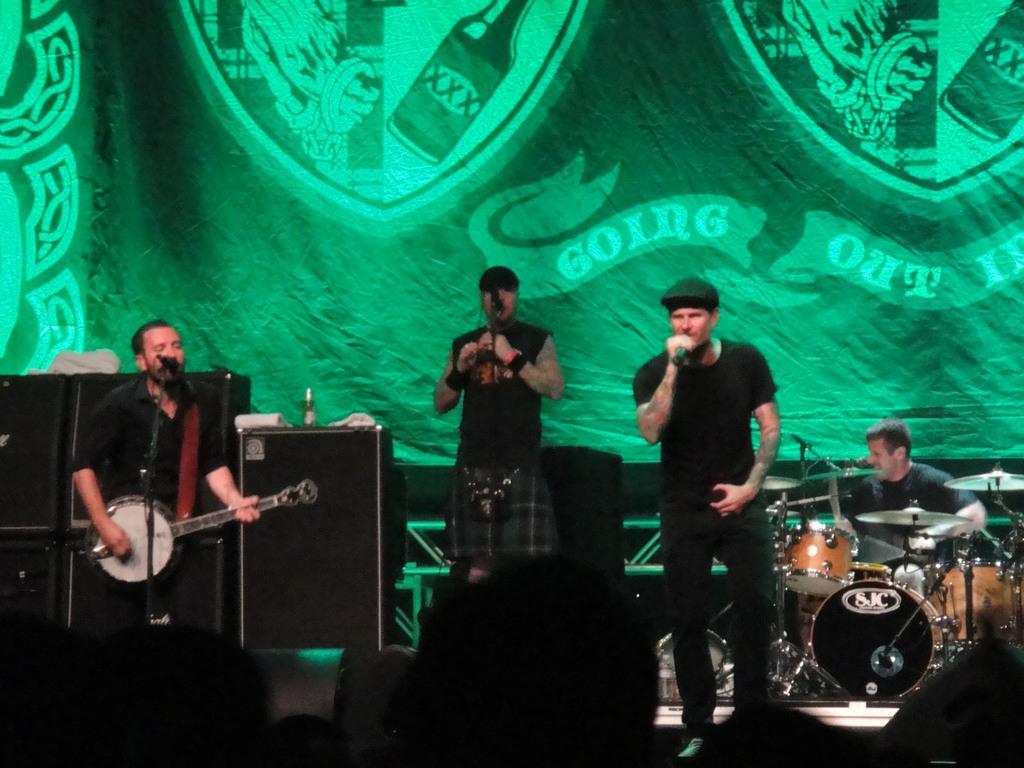Describe this image in one or two sentences. There are three people standing and singing a song. This is a speaker. Here is another person sitting and playing drums. At background I can see a cloth hanging with some print on it. 